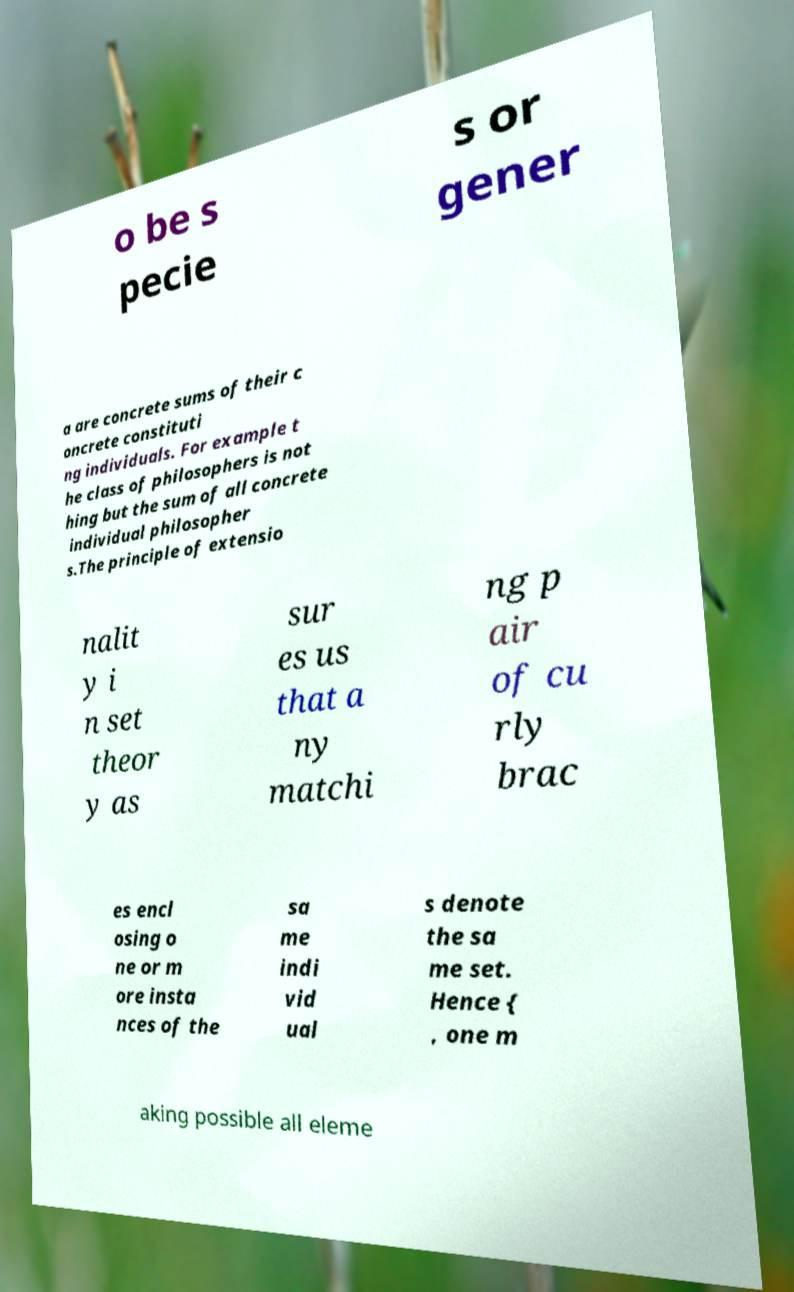Please identify and transcribe the text found in this image. o be s pecie s or gener a are concrete sums of their c oncrete constituti ng individuals. For example t he class of philosophers is not hing but the sum of all concrete individual philosopher s.The principle of extensio nalit y i n set theor y as sur es us that a ny matchi ng p air of cu rly brac es encl osing o ne or m ore insta nces of the sa me indi vid ual s denote the sa me set. Hence { , one m aking possible all eleme 